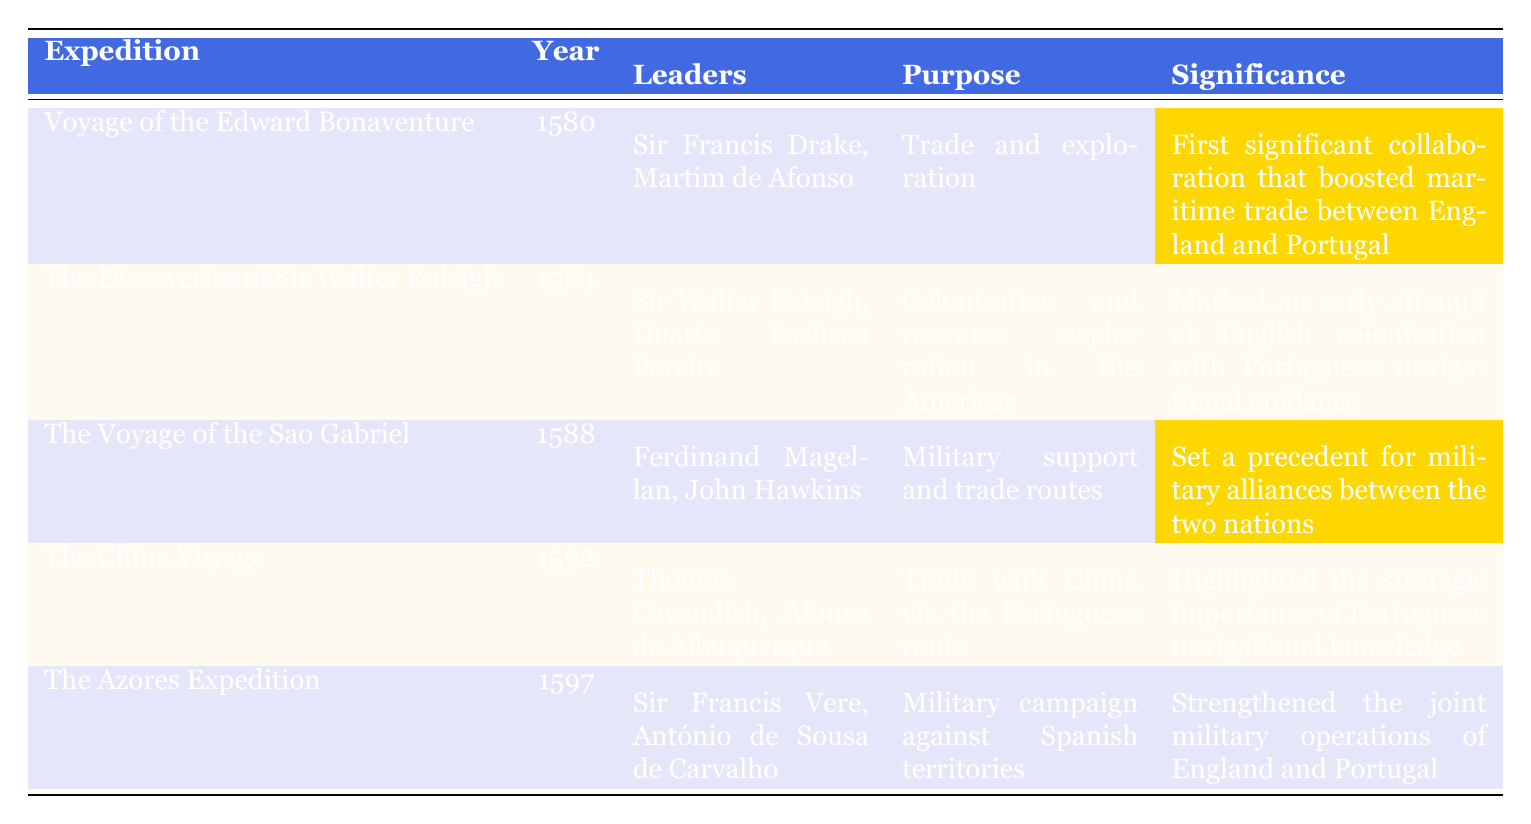What is the purpose of "The Voyage of the Edward Bonaventure"? The table explicitly states that its purpose was "Trade and exploration."
Answer: Trade and exploration Who led "The Discoveries of Sir Walter Raleigh"? The table indicates that the leaders were "Sir Walter Raleigh" and "Duarte Pacheco Pereira."
Answer: Sir Walter Raleigh and Duarte Pacheco Pereira In what year did "The Azores Expedition" occur? The year is listed in the table alongside the expedition name, which is 1597.
Answer: 1597 Which expedition highlighted the strategic importance of Portuguese navigational knowledge? The table states that "The China Voyage" highlighted this significance.
Answer: The China Voyage How many expeditions were conducted between 1580 and 1592? The relevant expeditions within this timeframe are: "Voyage of the Edward Bonaventure," "The Discoveries of Sir Walter Raleigh," and "The China Voyage," totaling three expeditions.
Answer: 3 Was "The Voyage of the Sao Gabriel" focused on trade routes? Yes, the purpose listed in the table mentions "Military support and trade routes."
Answer: Yes Which expedition had the outcome of capturing strategic locations in the Azores? According to the table, "The Azores Expedition" had this outcome.
Answer: The Azores Expedition Which expedition signifies the first significant collaboration that boosted maritime trade between England and Portugal? The table highlights that this significance belongs to "Voyage of the Edward Bonaventure."
Answer: Voyage of the Edward Bonaventure What is the outcome of "The Discoveries of Sir Walter Raleigh"? The outcome in the table states that it "Founded the Roanoke Colony; however, it faced a lack of support from both nations."
Answer: Founded the Roanoke Colony; faced lack of support Can you name one leader from each of the expeditions listed? The leaders from each expedition can be found in the table: 1) "Sir Francis Drake, Martim de Afonso" 2) "Sir Walter Raleigh, Duarte Pacheco Pereira" 3) "Ferdinand Magellan, John Hawkins" 4) "Thomas Cavendish, Afonso de Albuquerque" 5) "Sir Francis Vere, António de Sousa de Carvalho."
Answer: Yes, the leaders are provided for each expedition 